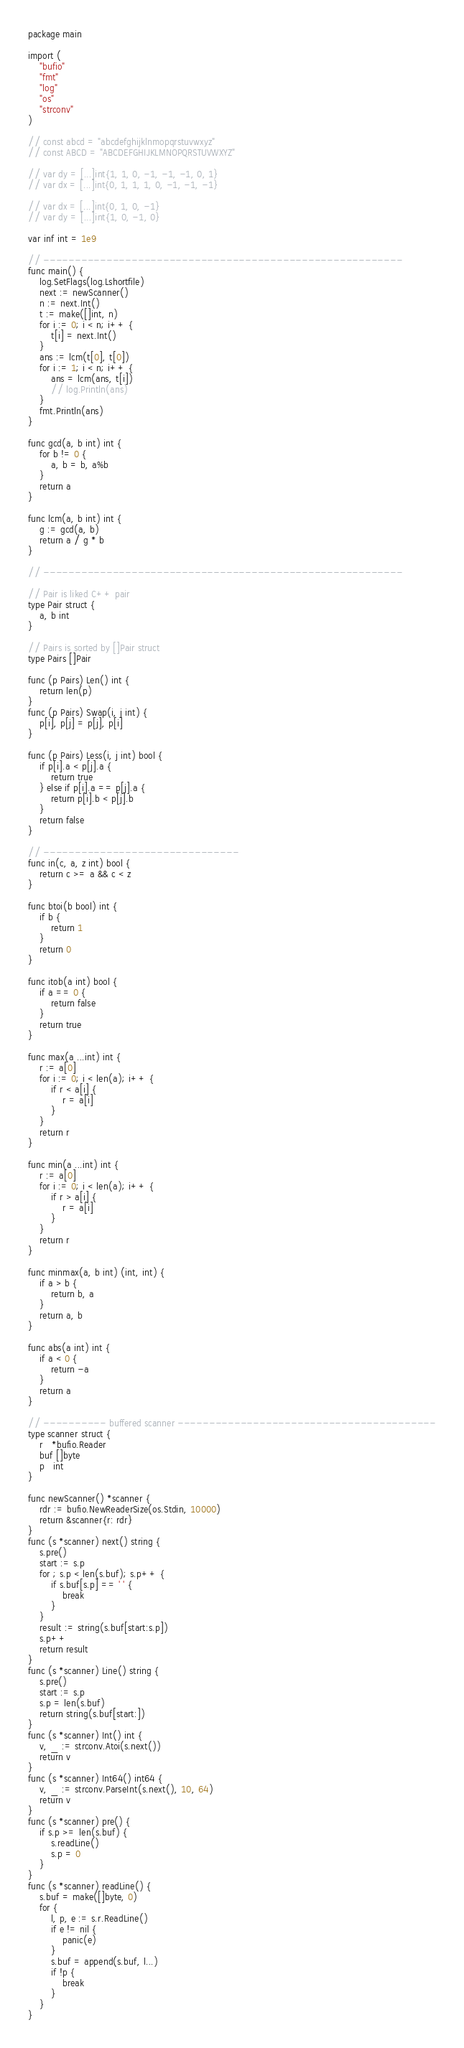<code> <loc_0><loc_0><loc_500><loc_500><_Go_>package main

import (
	"bufio"
	"fmt"
	"log"
	"os"
	"strconv"
)

// const abcd = "abcdefghijklnmopqrstuvwxyz"
// const ABCD = "ABCDEFGHIJKLMNOPQRSTUVWXYZ"

// var dy = [...]int{1, 1, 0, -1, -1, -1, 0, 1}
// var dx = [...]int{0, 1, 1, 1, 0, -1, -1, -1}

// var dx = [...]int{0, 1, 0, -1}
// var dy = [...]int{1, 0, -1, 0}

var inf int = 1e9

// ---------------------------------------------------------
func main() {
	log.SetFlags(log.Lshortfile)
	next := newScanner()
	n := next.Int()
	t := make([]int, n)
	for i := 0; i < n; i++ {
		t[i] = next.Int()
	}
	ans := lcm(t[0], t[0])
	for i := 1; i < n; i++ {
		ans = lcm(ans, t[i])
		// log.Println(ans)
	}
	fmt.Println(ans)
}

func gcd(a, b int) int {
	for b != 0 {
		a, b = b, a%b
	}
	return a
}

func lcm(a, b int) int {
	g := gcd(a, b)
	return a / g * b
}

// ---------------------------------------------------------

// Pair is liked C++ pair
type Pair struct {
	a, b int
}

// Pairs is sorted by []Pair struct
type Pairs []Pair

func (p Pairs) Len() int {
	return len(p)
}
func (p Pairs) Swap(i, j int) {
	p[i], p[j] = p[j], p[i]
}

func (p Pairs) Less(i, j int) bool {
	if p[i].a < p[j].a {
		return true
	} else if p[i].a == p[j].a {
		return p[i].b < p[j].b
	}
	return false
}

// -------------------------------
func in(c, a, z int) bool {
	return c >= a && c < z
}

func btoi(b bool) int {
	if b {
		return 1
	}
	return 0
}

func itob(a int) bool {
	if a == 0 {
		return false
	}
	return true
}

func max(a ...int) int {
	r := a[0]
	for i := 0; i < len(a); i++ {
		if r < a[i] {
			r = a[i]
		}
	}
	return r
}

func min(a ...int) int {
	r := a[0]
	for i := 0; i < len(a); i++ {
		if r > a[i] {
			r = a[i]
		}
	}
	return r
}

func minmax(a, b int) (int, int) {
	if a > b {
		return b, a
	}
	return a, b
}

func abs(a int) int {
	if a < 0 {
		return -a
	}
	return a
}

// ---------- buffered scanner -----------------------------------------
type scanner struct {
	r   *bufio.Reader
	buf []byte
	p   int
}

func newScanner() *scanner {
	rdr := bufio.NewReaderSize(os.Stdin, 10000)
	return &scanner{r: rdr}
}
func (s *scanner) next() string {
	s.pre()
	start := s.p
	for ; s.p < len(s.buf); s.p++ {
		if s.buf[s.p] == ' ' {
			break
		}
	}
	result := string(s.buf[start:s.p])
	s.p++
	return result
}
func (s *scanner) Line() string {
	s.pre()
	start := s.p
	s.p = len(s.buf)
	return string(s.buf[start:])
}
func (s *scanner) Int() int {
	v, _ := strconv.Atoi(s.next())
	return v
}
func (s *scanner) Int64() int64 {
	v, _ := strconv.ParseInt(s.next(), 10, 64)
	return v
}
func (s *scanner) pre() {
	if s.p >= len(s.buf) {
		s.readLine()
		s.p = 0
	}
}
func (s *scanner) readLine() {
	s.buf = make([]byte, 0)
	for {
		l, p, e := s.r.ReadLine()
		if e != nil {
			panic(e)
		}
		s.buf = append(s.buf, l...)
		if !p {
			break
		}
	}
}
</code> 